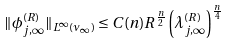Convert formula to latex. <formula><loc_0><loc_0><loc_500><loc_500>\| \phi _ { j , \infty } ^ { ( R ) } \| _ { L ^ { \infty } ( \nu _ { \infty } ) } \leq C ( n ) R ^ { \frac { n } { 2 } } \left ( \lambda _ { j , \infty } ^ { ( R ) } \right ) ^ { \frac { n } { 4 } }</formula> 